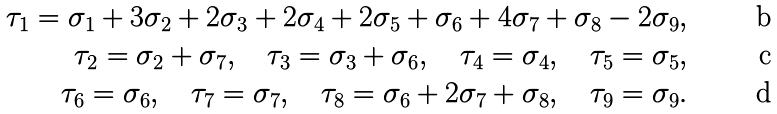Convert formula to latex. <formula><loc_0><loc_0><loc_500><loc_500>\tau _ { 1 } = \sigma _ { 1 } + 3 \sigma _ { 2 } + 2 \sigma _ { 3 } + 2 \sigma _ { 4 } + 2 \sigma _ { 5 } + \sigma _ { 6 } + 4 \sigma _ { 7 } + \sigma _ { 8 } - 2 \sigma _ { 9 } , \\ \tau _ { 2 } = \sigma _ { 2 } + \sigma _ { 7 } , \quad \tau _ { 3 } = \sigma _ { 3 } + \sigma _ { 6 } , \quad \tau _ { 4 } = \sigma _ { 4 } , \quad \tau _ { 5 } = \sigma _ { 5 } , \\ \tau _ { 6 } = \sigma _ { 6 } , \quad \tau _ { 7 } = \sigma _ { 7 } , \quad \tau _ { 8 } = \sigma _ { 6 } + 2 \sigma _ { 7 } + \sigma _ { 8 } , \quad \tau _ { 9 } = \sigma _ { 9 } .</formula> 